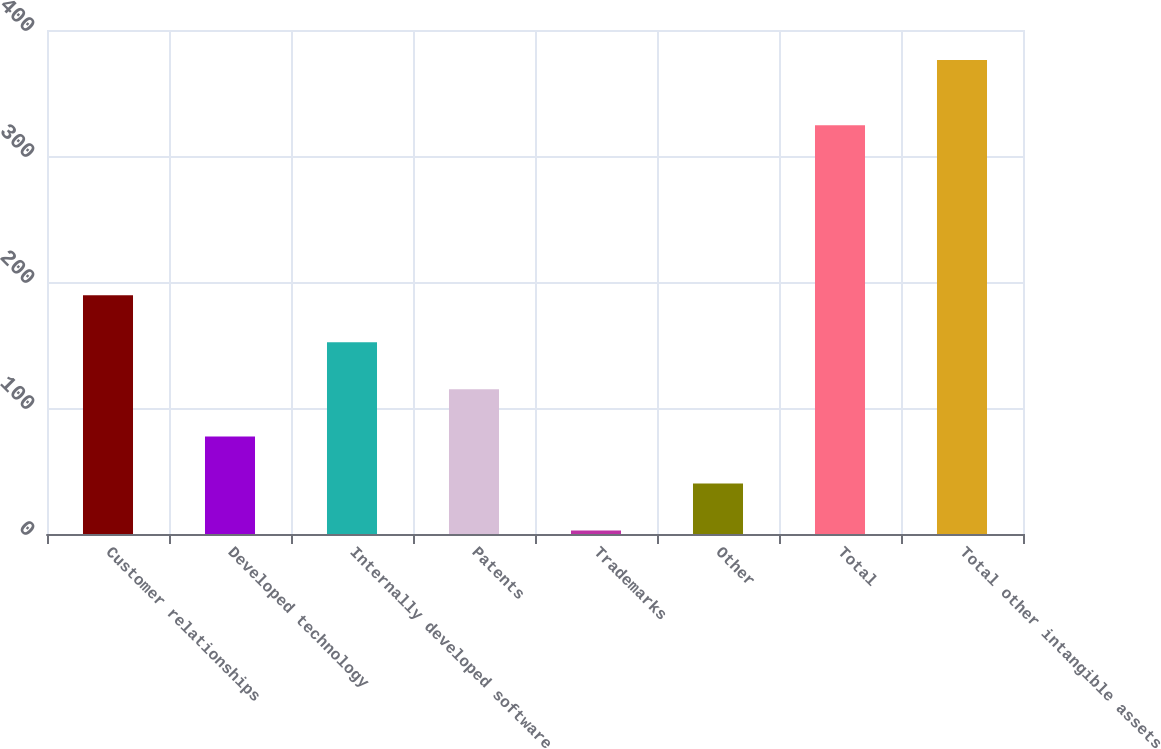Convert chart. <chart><loc_0><loc_0><loc_500><loc_500><bar_chart><fcel>Customer relationships<fcel>Developed technology<fcel>Internally developed software<fcel>Patents<fcel>Trademarks<fcel>Other<fcel>Total<fcel>Total other intangible assets<nl><fcel>189.45<fcel>77.46<fcel>152.12<fcel>114.79<fcel>2.8<fcel>40.13<fcel>324.5<fcel>376.1<nl></chart> 